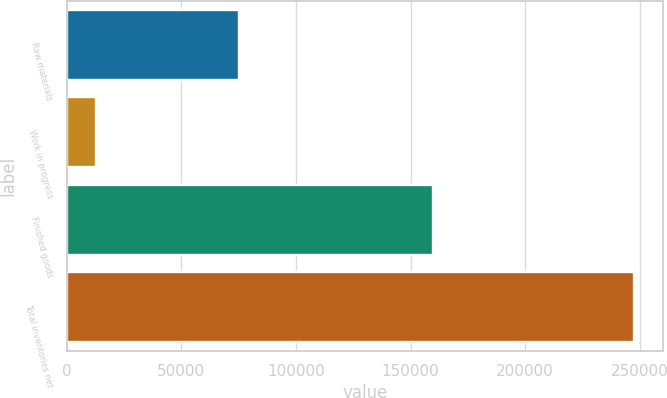Convert chart to OTSL. <chart><loc_0><loc_0><loc_500><loc_500><bar_chart><fcel>Raw materials<fcel>Work in progress<fcel>Finished goods<fcel>Total inventories net<nl><fcel>74924<fcel>12768<fcel>159996<fcel>247688<nl></chart> 